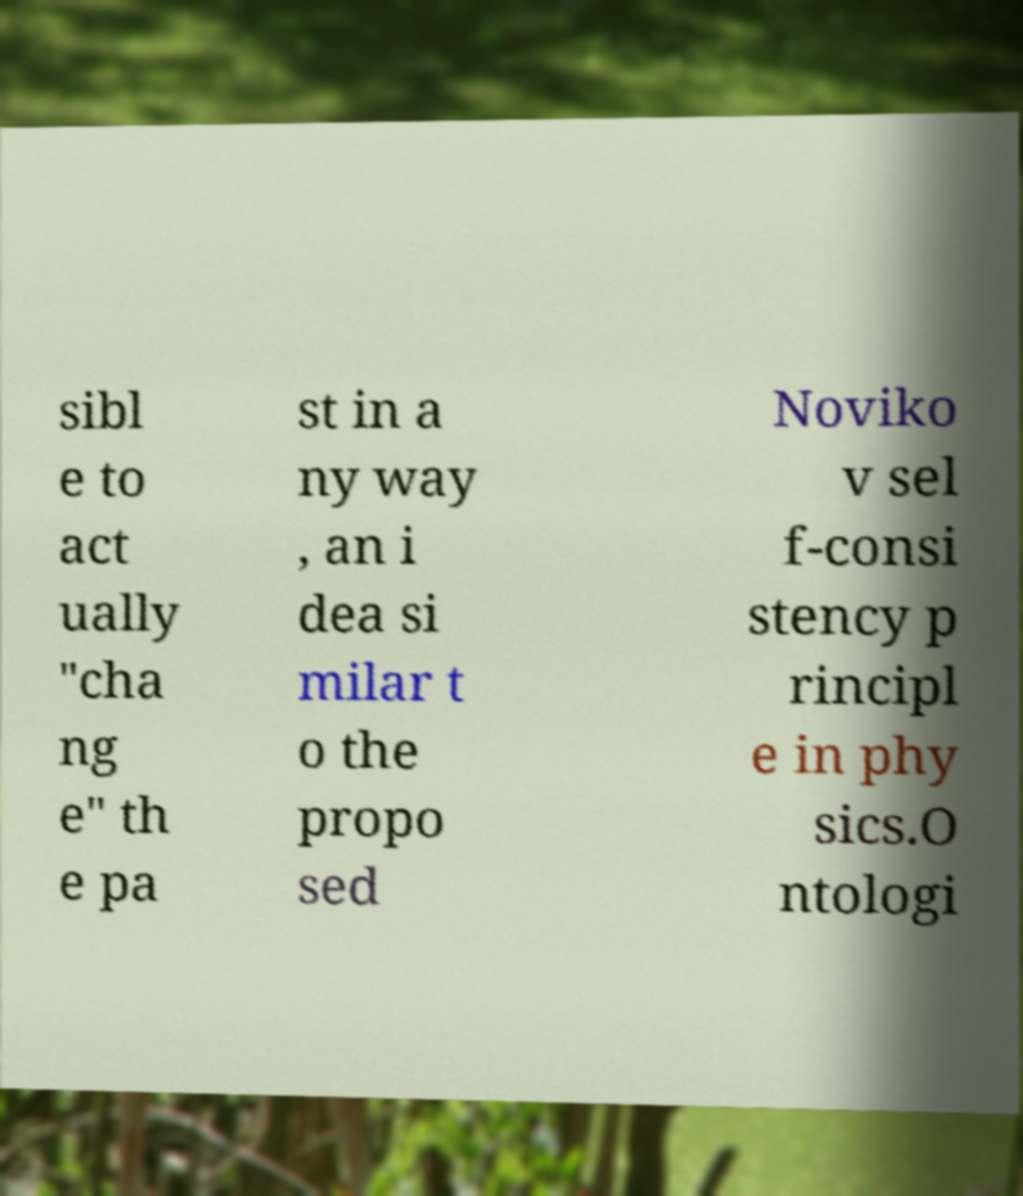There's text embedded in this image that I need extracted. Can you transcribe it verbatim? sibl e to act ually "cha ng e" th e pa st in a ny way , an i dea si milar t o the propo sed Noviko v sel f-consi stency p rincipl e in phy sics.O ntologi 